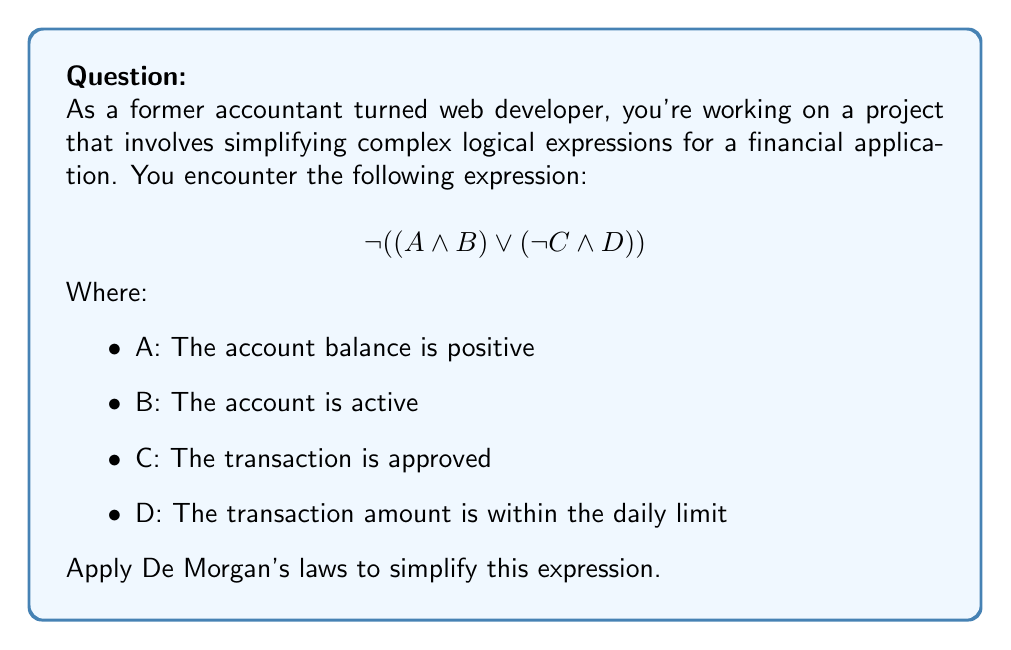Show me your answer to this math problem. Let's apply De Morgan's laws step by step to simplify the given expression:

1) First, we'll apply De Morgan's law to the outermost negation:
   $$ \neg ((A \land B) \lor (\neg C \land D)) $$
   becomes
   $$ (\neg(A \land B)) \land (\neg(\neg C \land D)) $$

2) Now, we apply De Morgan's law to each part separately:

   For $(A \land B)$:
   $$ \neg(A \land B) = (\neg A \lor \neg B) $$

   For $(\neg C \land D)$:
   $$ \neg(\neg C \land D) = (C \lor \neg D) $$

3) Substituting these back into our expression:
   $$ (\neg A \lor \neg B) \land (C \lor \neg D) $$

4) This is the simplified form using De Morgan's laws. In terms of our financial application, this expression means:
   (The account balance is not positive OR the account is not active) AND (The transaction is approved OR the transaction amount is not within the daily limit)
Answer: $$ (\neg A \lor \neg B) \land (C \lor \neg D) $$ 